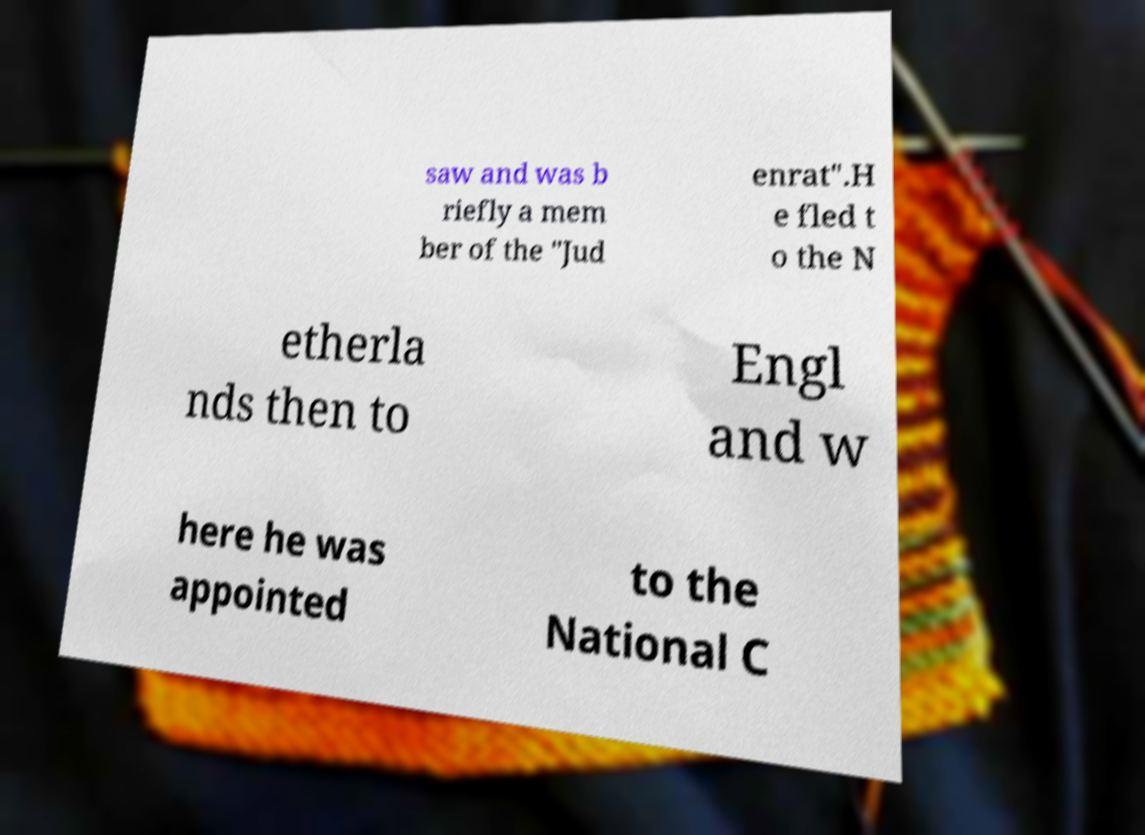Could you extract and type out the text from this image? saw and was b riefly a mem ber of the "Jud enrat".H e fled t o the N etherla nds then to Engl and w here he was appointed to the National C 